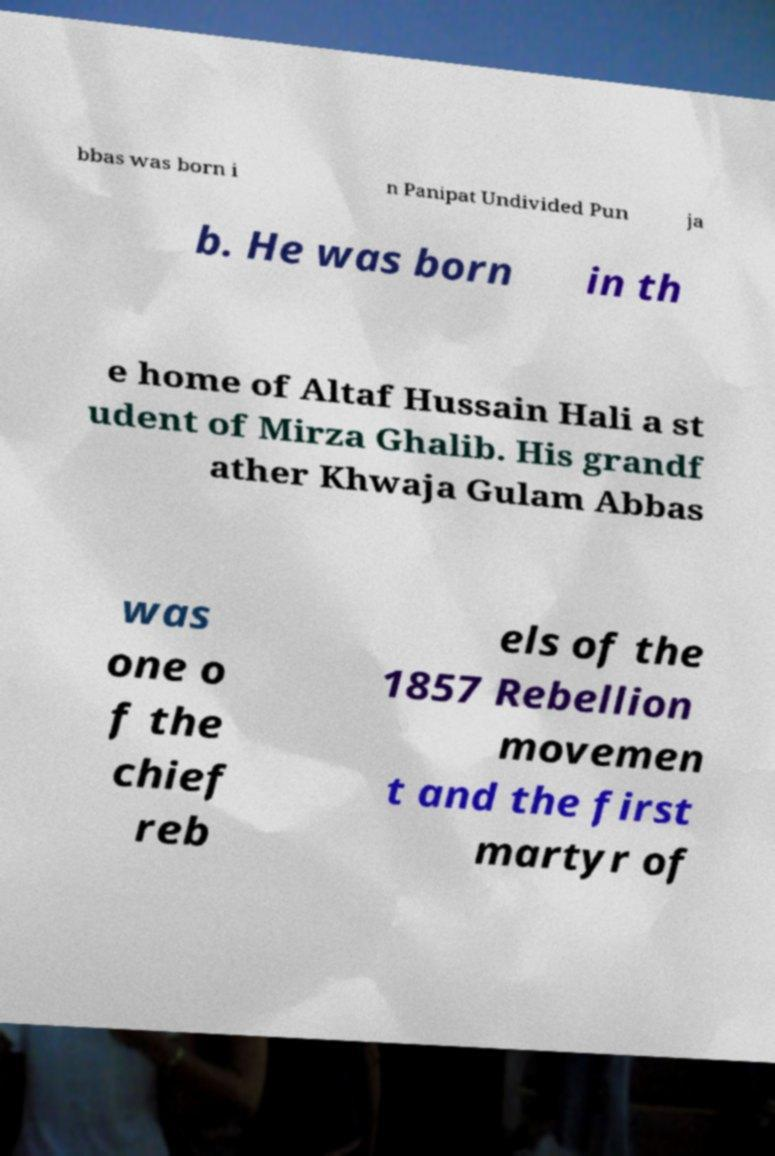For documentation purposes, I need the text within this image transcribed. Could you provide that? bbas was born i n Panipat Undivided Pun ja b. He was born in th e home of Altaf Hussain Hali a st udent of Mirza Ghalib. His grandf ather Khwaja Gulam Abbas was one o f the chief reb els of the 1857 Rebellion movemen t and the first martyr of 